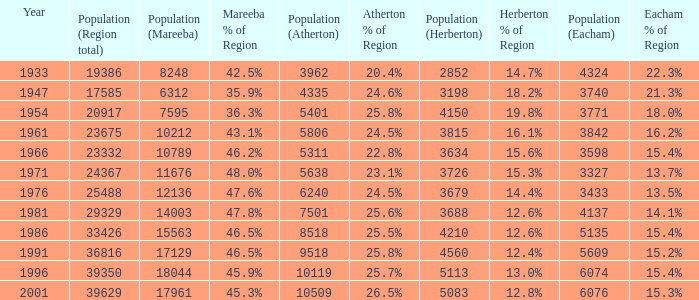What was the smallest population figure for Mareeba? 6312.0. 